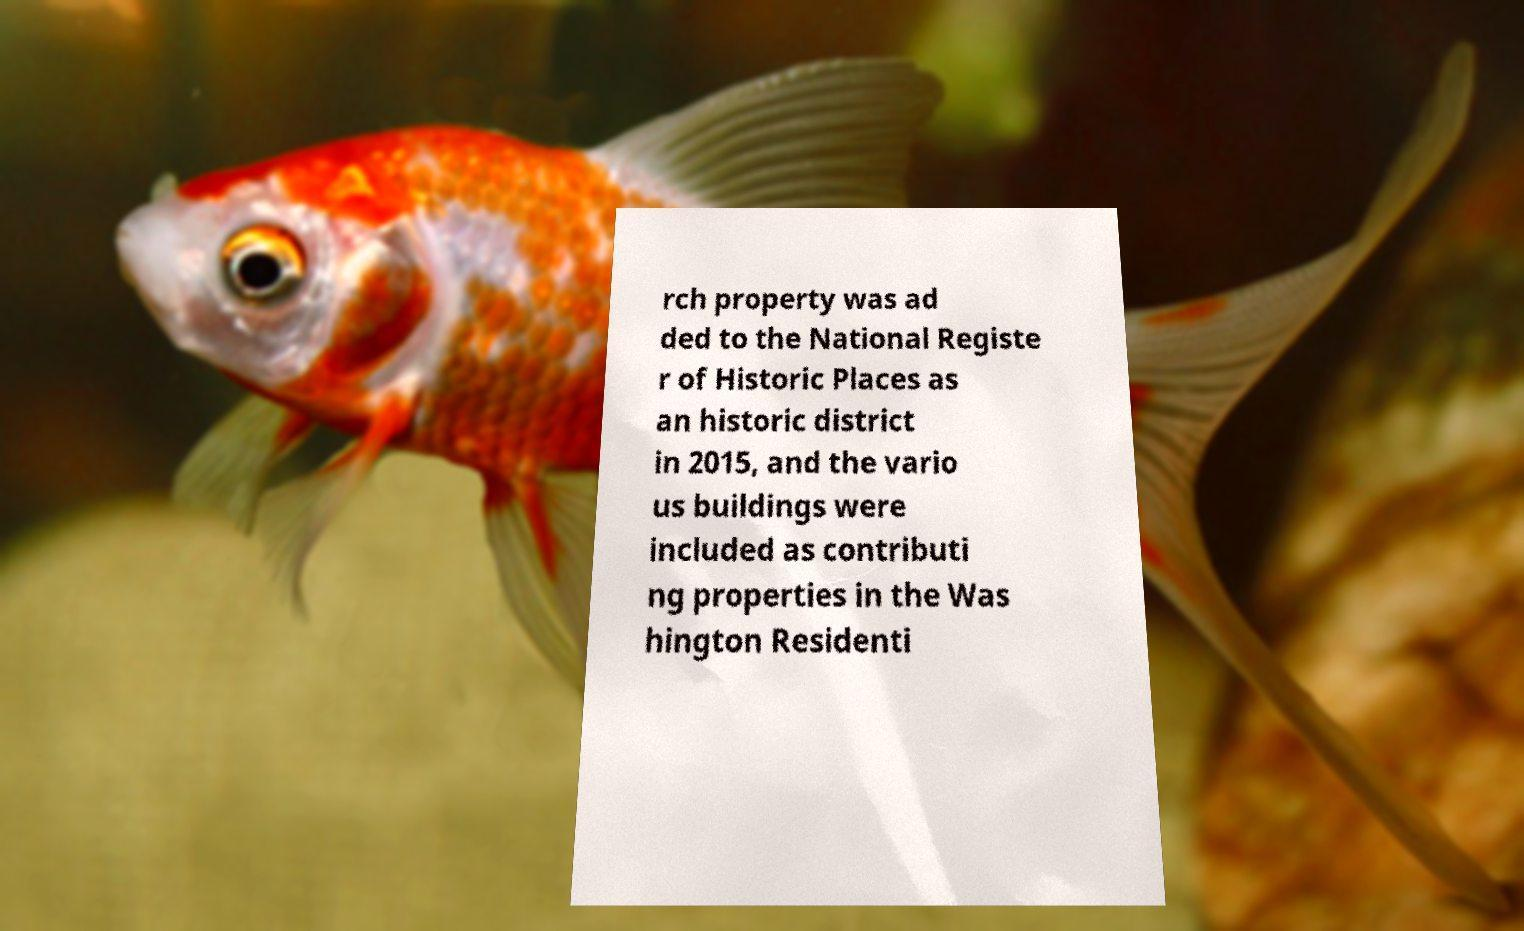What messages or text are displayed in this image? I need them in a readable, typed format. rch property was ad ded to the National Registe r of Historic Places as an historic district in 2015, and the vario us buildings were included as contributi ng properties in the Was hington Residenti 